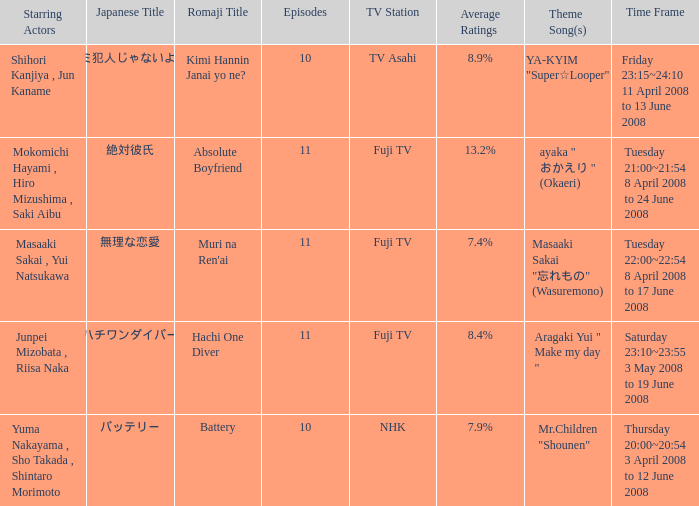How many titles had an average rating of 8.9%? 1.0. 